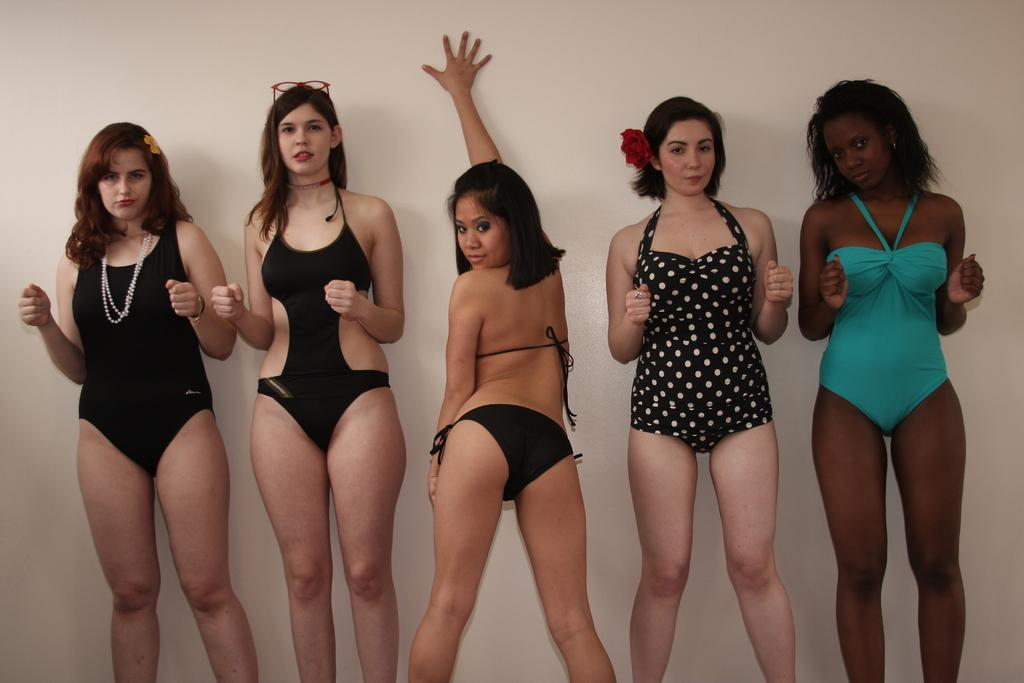What can be seen in the image? There are ladies standing in the image. What is visible in the background of the image? There is a wall in the background of the image. Can you describe any specific features of the ladies? One lady is wearing glasses, and another lady has a flower on her head. What type of feast is being prepared by the ladies in the image? There is no indication in the image that the ladies are preparing a feast or any food. 